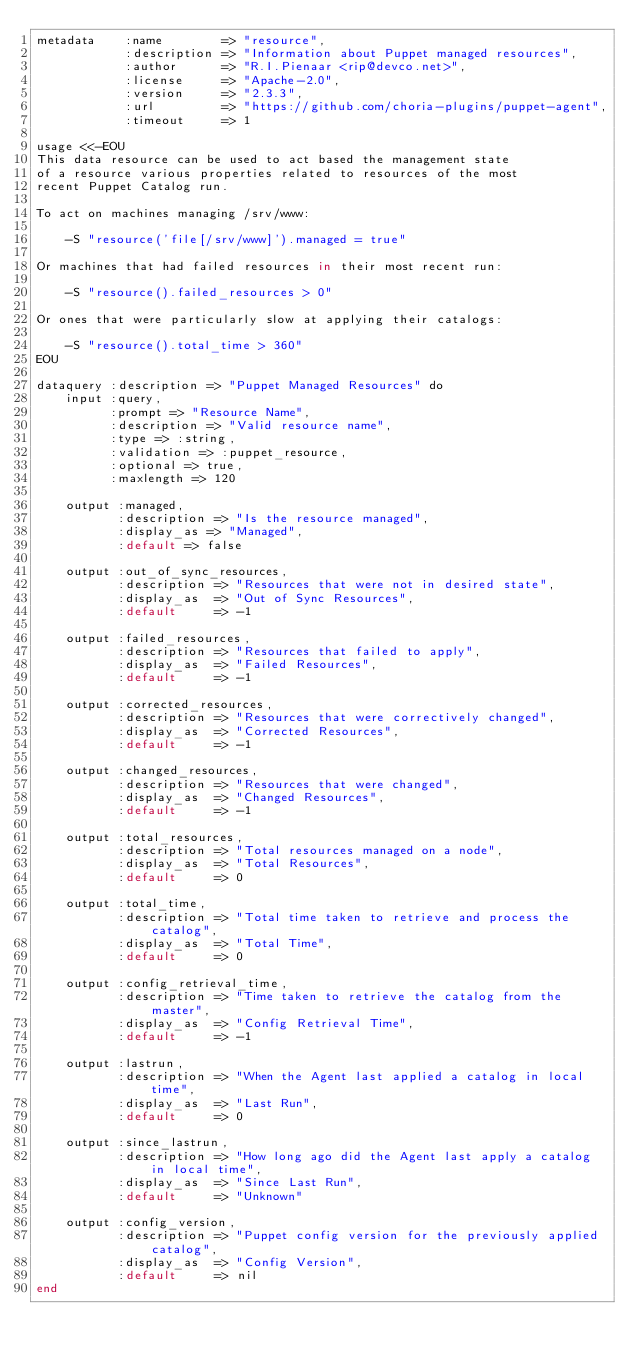<code> <loc_0><loc_0><loc_500><loc_500><_SQL_>metadata    :name        => "resource",
            :description => "Information about Puppet managed resources",
            :author      => "R.I.Pienaar <rip@devco.net>",
            :license     => "Apache-2.0",
            :version     => "2.3.3",
            :url         => "https://github.com/choria-plugins/puppet-agent",
            :timeout     => 1

usage <<-EOU
This data resource can be used to act based the management state
of a resource various properties related to resources of the most
recent Puppet Catalog run.

To act on machines managing /srv/www:

    -S "resource('file[/srv/www]').managed = true"

Or machines that had failed resources in their most recent run:

    -S "resource().failed_resources > 0"

Or ones that were particularly slow at applying their catalogs:

    -S "resource().total_time > 360"
EOU

dataquery :description => "Puppet Managed Resources" do
    input :query,
          :prompt => "Resource Name",
          :description => "Valid resource name",
          :type => :string,
          :validation => :puppet_resource,
          :optional => true,
          :maxlength => 120

    output :managed,
           :description => "Is the resource managed",
           :display_as => "Managed",
           :default => false

    output :out_of_sync_resources,
           :description => "Resources that were not in desired state",
           :display_as  => "Out of Sync Resources",
           :default     => -1

    output :failed_resources,
           :description => "Resources that failed to apply",
           :display_as  => "Failed Resources",
           :default     => -1

    output :corrected_resources,
           :description => "Resources that were correctively changed",
           :display_as  => "Corrected Resources",
           :default     => -1

    output :changed_resources,
           :description => "Resources that were changed",
           :display_as  => "Changed Resources",
           :default     => -1

    output :total_resources,
           :description => "Total resources managed on a node",
           :display_as  => "Total Resources",
           :default     => 0

    output :total_time,
           :description => "Total time taken to retrieve and process the catalog",
           :display_as  => "Total Time",
           :default     => 0

    output :config_retrieval_time,
           :description => "Time taken to retrieve the catalog from the master",
           :display_as  => "Config Retrieval Time",
           :default     => -1

    output :lastrun,
           :description => "When the Agent last applied a catalog in local time",
           :display_as  => "Last Run",
           :default     => 0

    output :since_lastrun,
           :description => "How long ago did the Agent last apply a catalog in local time",
           :display_as  => "Since Last Run",
           :default     => "Unknown"

    output :config_version,
           :description => "Puppet config version for the previously applied catalog",
           :display_as  => "Config Version",
           :default     => nil
end
</code> 